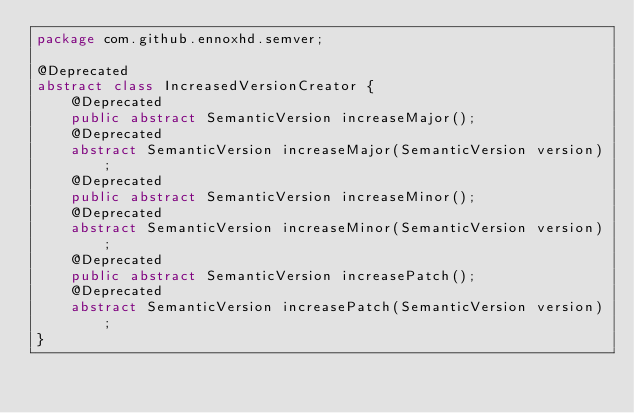<code> <loc_0><loc_0><loc_500><loc_500><_Java_>package com.github.ennoxhd.semver;

@Deprecated
abstract class IncreasedVersionCreator {
	@Deprecated
	public abstract SemanticVersion increaseMajor();
	@Deprecated
	abstract SemanticVersion increaseMajor(SemanticVersion version);
	@Deprecated
	public abstract SemanticVersion increaseMinor();
	@Deprecated
	abstract SemanticVersion increaseMinor(SemanticVersion version);
	@Deprecated
	public abstract SemanticVersion increasePatch();
	@Deprecated
	abstract SemanticVersion increasePatch(SemanticVersion version);
}
</code> 